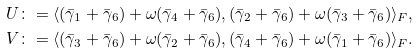<formula> <loc_0><loc_0><loc_500><loc_500>U & \colon = \langle ( \bar { \gamma } _ { 1 } + \bar { \gamma } _ { 6 } ) + \omega ( \bar { \gamma } _ { 4 } + \bar { \gamma } _ { 6 } ) , ( \bar { \gamma } _ { 2 } + \bar { \gamma } _ { 6 } ) + \omega ( \bar { \gamma } _ { 3 } + \bar { \gamma } _ { 6 } ) \rangle _ { F } , \\ V & \colon = \langle ( \bar { \gamma } _ { 3 } + \bar { \gamma } _ { 6 } ) + \omega ( \bar { \gamma } _ { 2 } + \bar { \gamma } _ { 6 } ) , ( \bar { \gamma } _ { 4 } + \bar { \gamma } _ { 6 } ) + \omega ( \bar { \gamma } _ { 1 } + \bar { \gamma } _ { 6 } ) \rangle _ { F } .</formula> 